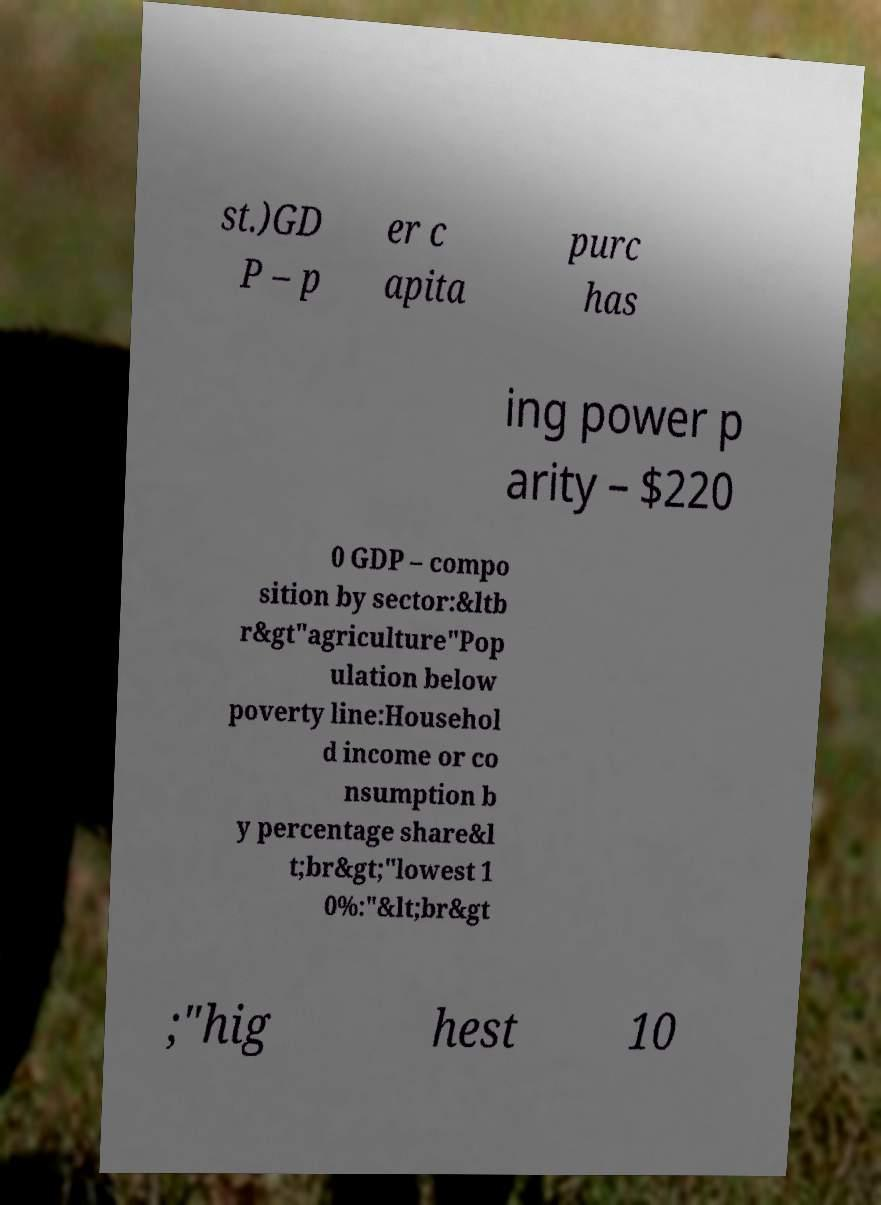Could you assist in decoding the text presented in this image and type it out clearly? st.)GD P – p er c apita purc has ing power p arity – $220 0 GDP – compo sition by sector:&ltb r&gt"agriculture"Pop ulation below poverty line:Househol d income or co nsumption b y percentage share&l t;br&gt;"lowest 1 0%:"&lt;br&gt ;"hig hest 10 